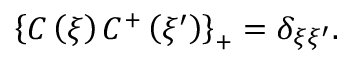Convert formula to latex. <formula><loc_0><loc_0><loc_500><loc_500>\left \{ C \left ( \xi \right ) C ^ { + } \left ( \xi ^ { \prime } \right ) \right \} _ { + } = \delta _ { \xi \xi ^ { \prime } } .</formula> 